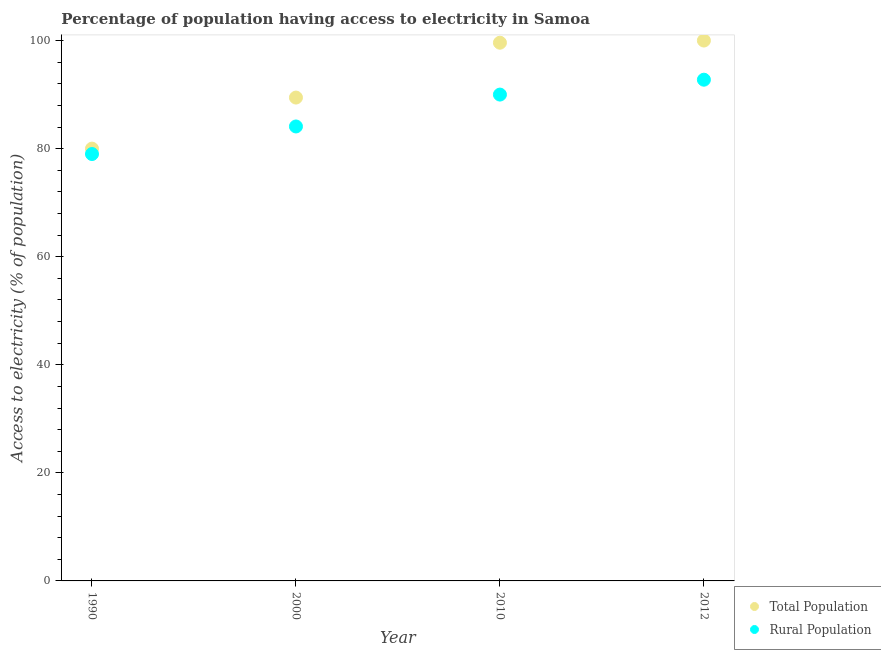What is the percentage of population having access to electricity in 1990?
Offer a very short reply. 80. Across all years, what is the minimum percentage of rural population having access to electricity?
Offer a terse response. 79. In which year was the percentage of rural population having access to electricity minimum?
Keep it short and to the point. 1990. What is the total percentage of rural population having access to electricity in the graph?
Ensure brevity in your answer.  345.86. What is the difference between the percentage of population having access to electricity in 2010 and the percentage of rural population having access to electricity in 1990?
Offer a very short reply. 20.6. What is the average percentage of population having access to electricity per year?
Your answer should be compact. 92.26. In the year 2012, what is the difference between the percentage of population having access to electricity and percentage of rural population having access to electricity?
Give a very brief answer. 7.25. In how many years, is the percentage of rural population having access to electricity greater than 8 %?
Ensure brevity in your answer.  4. What is the ratio of the percentage of population having access to electricity in 2000 to that in 2012?
Provide a succinct answer. 0.89. Is the percentage of rural population having access to electricity in 1990 less than that in 2000?
Keep it short and to the point. Yes. Is the difference between the percentage of population having access to electricity in 2000 and 2012 greater than the difference between the percentage of rural population having access to electricity in 2000 and 2012?
Keep it short and to the point. No. What is the difference between the highest and the second highest percentage of population having access to electricity?
Keep it short and to the point. 0.4. What is the difference between the highest and the lowest percentage of rural population having access to electricity?
Keep it short and to the point. 13.75. In how many years, is the percentage of population having access to electricity greater than the average percentage of population having access to electricity taken over all years?
Offer a very short reply. 2. Is the sum of the percentage of population having access to electricity in 1990 and 2000 greater than the maximum percentage of rural population having access to electricity across all years?
Your answer should be compact. Yes. Does the percentage of population having access to electricity monotonically increase over the years?
Offer a very short reply. Yes. Is the percentage of population having access to electricity strictly greater than the percentage of rural population having access to electricity over the years?
Your response must be concise. Yes. What is the difference between two consecutive major ticks on the Y-axis?
Ensure brevity in your answer.  20. Does the graph contain any zero values?
Keep it short and to the point. No. Where does the legend appear in the graph?
Offer a terse response. Bottom right. How are the legend labels stacked?
Give a very brief answer. Vertical. What is the title of the graph?
Provide a short and direct response. Percentage of population having access to electricity in Samoa. Does "Urban" appear as one of the legend labels in the graph?
Make the answer very short. No. What is the label or title of the Y-axis?
Ensure brevity in your answer.  Access to electricity (% of population). What is the Access to electricity (% of population) in Total Population in 1990?
Make the answer very short. 80. What is the Access to electricity (% of population) in Rural Population in 1990?
Keep it short and to the point. 79. What is the Access to electricity (% of population) of Total Population in 2000?
Offer a terse response. 89.45. What is the Access to electricity (% of population) of Rural Population in 2000?
Provide a short and direct response. 84.1. What is the Access to electricity (% of population) in Total Population in 2010?
Make the answer very short. 99.6. What is the Access to electricity (% of population) of Total Population in 2012?
Your response must be concise. 100. What is the Access to electricity (% of population) of Rural Population in 2012?
Your answer should be compact. 92.75. Across all years, what is the maximum Access to electricity (% of population) in Rural Population?
Provide a short and direct response. 92.75. Across all years, what is the minimum Access to electricity (% of population) of Rural Population?
Ensure brevity in your answer.  79. What is the total Access to electricity (% of population) in Total Population in the graph?
Provide a short and direct response. 369.05. What is the total Access to electricity (% of population) in Rural Population in the graph?
Your answer should be very brief. 345.86. What is the difference between the Access to electricity (% of population) in Total Population in 1990 and that in 2000?
Your response must be concise. -9.45. What is the difference between the Access to electricity (% of population) of Rural Population in 1990 and that in 2000?
Offer a terse response. -5.1. What is the difference between the Access to electricity (% of population) of Total Population in 1990 and that in 2010?
Keep it short and to the point. -19.6. What is the difference between the Access to electricity (% of population) in Rural Population in 1990 and that in 2010?
Your answer should be very brief. -11. What is the difference between the Access to electricity (% of population) in Total Population in 1990 and that in 2012?
Your response must be concise. -20. What is the difference between the Access to electricity (% of population) in Rural Population in 1990 and that in 2012?
Give a very brief answer. -13.75. What is the difference between the Access to electricity (% of population) in Total Population in 2000 and that in 2010?
Make the answer very short. -10.15. What is the difference between the Access to electricity (% of population) in Rural Population in 2000 and that in 2010?
Your response must be concise. -5.9. What is the difference between the Access to electricity (% of population) of Total Population in 2000 and that in 2012?
Your response must be concise. -10.55. What is the difference between the Access to electricity (% of population) in Rural Population in 2000 and that in 2012?
Provide a succinct answer. -8.65. What is the difference between the Access to electricity (% of population) of Rural Population in 2010 and that in 2012?
Provide a short and direct response. -2.75. What is the difference between the Access to electricity (% of population) in Total Population in 1990 and the Access to electricity (% of population) in Rural Population in 2000?
Your answer should be very brief. -4.1. What is the difference between the Access to electricity (% of population) in Total Population in 1990 and the Access to electricity (% of population) in Rural Population in 2010?
Provide a short and direct response. -10. What is the difference between the Access to electricity (% of population) in Total Population in 1990 and the Access to electricity (% of population) in Rural Population in 2012?
Your answer should be compact. -12.75. What is the difference between the Access to electricity (% of population) of Total Population in 2000 and the Access to electricity (% of population) of Rural Population in 2010?
Offer a very short reply. -0.55. What is the difference between the Access to electricity (% of population) of Total Population in 2000 and the Access to electricity (% of population) of Rural Population in 2012?
Keep it short and to the point. -3.31. What is the difference between the Access to electricity (% of population) in Total Population in 2010 and the Access to electricity (% of population) in Rural Population in 2012?
Offer a very short reply. 6.85. What is the average Access to electricity (% of population) of Total Population per year?
Keep it short and to the point. 92.26. What is the average Access to electricity (% of population) in Rural Population per year?
Ensure brevity in your answer.  86.46. In the year 2000, what is the difference between the Access to electricity (% of population) in Total Population and Access to electricity (% of population) in Rural Population?
Ensure brevity in your answer.  5.35. In the year 2012, what is the difference between the Access to electricity (% of population) of Total Population and Access to electricity (% of population) of Rural Population?
Your answer should be very brief. 7.25. What is the ratio of the Access to electricity (% of population) in Total Population in 1990 to that in 2000?
Keep it short and to the point. 0.89. What is the ratio of the Access to electricity (% of population) of Rural Population in 1990 to that in 2000?
Offer a terse response. 0.94. What is the ratio of the Access to electricity (% of population) in Total Population in 1990 to that in 2010?
Provide a succinct answer. 0.8. What is the ratio of the Access to electricity (% of population) of Rural Population in 1990 to that in 2010?
Ensure brevity in your answer.  0.88. What is the ratio of the Access to electricity (% of population) in Total Population in 1990 to that in 2012?
Offer a terse response. 0.8. What is the ratio of the Access to electricity (% of population) of Rural Population in 1990 to that in 2012?
Your answer should be very brief. 0.85. What is the ratio of the Access to electricity (% of population) in Total Population in 2000 to that in 2010?
Ensure brevity in your answer.  0.9. What is the ratio of the Access to electricity (% of population) of Rural Population in 2000 to that in 2010?
Your response must be concise. 0.93. What is the ratio of the Access to electricity (% of population) of Total Population in 2000 to that in 2012?
Provide a short and direct response. 0.89. What is the ratio of the Access to electricity (% of population) of Rural Population in 2000 to that in 2012?
Provide a succinct answer. 0.91. What is the ratio of the Access to electricity (% of population) of Rural Population in 2010 to that in 2012?
Offer a very short reply. 0.97. What is the difference between the highest and the second highest Access to electricity (% of population) in Total Population?
Your response must be concise. 0.4. What is the difference between the highest and the second highest Access to electricity (% of population) of Rural Population?
Make the answer very short. 2.75. What is the difference between the highest and the lowest Access to electricity (% of population) in Total Population?
Give a very brief answer. 20. What is the difference between the highest and the lowest Access to electricity (% of population) of Rural Population?
Your answer should be very brief. 13.75. 